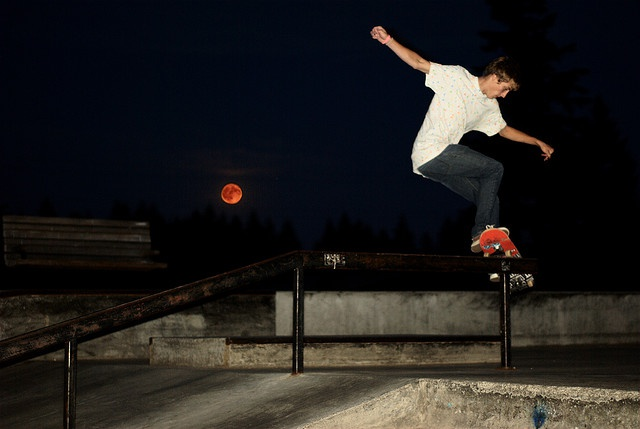Describe the objects in this image and their specific colors. I can see people in black, beige, and salmon tones, bench in black and gray tones, and skateboard in black, brown, red, and gray tones in this image. 